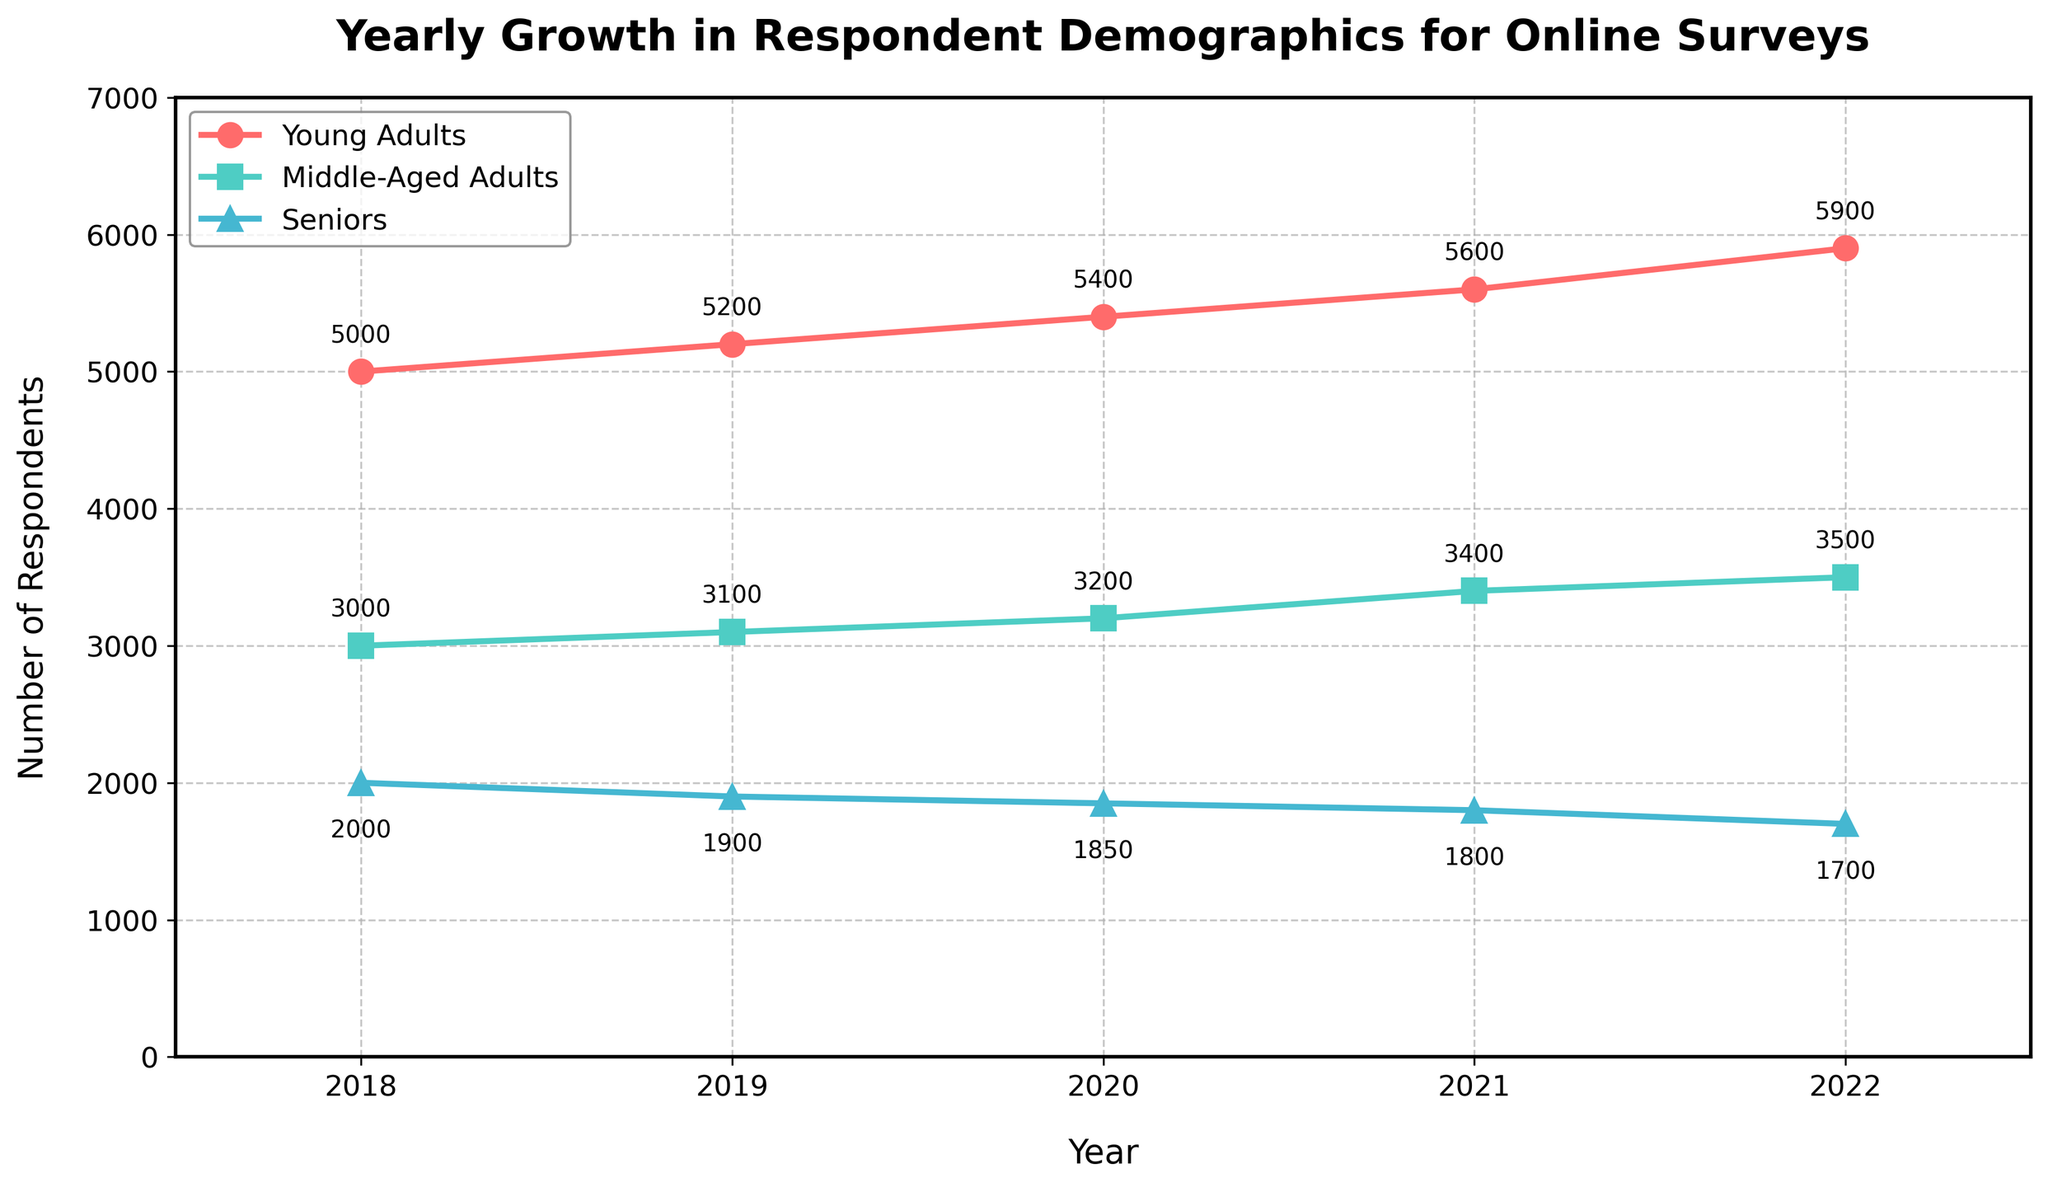What is the title of the plot? The title of the plot can be found at the top of the figure, stating the main subject being visualized. The title reads 'Yearly Growth in Respondent Demographics for Online Surveys'.
Answer: Yearly Growth in Respondent Demographics for Online Surveys What is the number of respondents in the Young Adults group in 2022? Locate the point for the year 2022 on the x-axis and then find the corresponding value on the y-axis for the Young Adults group, which is marked with red circles. The number next to the point indicates the value.
Answer: 5900 Which year had the highest number of Middle-Aged Adult respondents? Compare the values for Middle-Aged Adults, marked with green squares, across all years. The highest value is found in 2022.
Answer: 2022 What was the trend for the Seniors group from 2018 to 2022? Follow the points for the Seniors group, marked with blue triangles, from 2018 to 2022. The plot shows a decline over these years.
Answer: Declining How many more Young Adults were there than Seniors in 2021? Find the number of respondents for Young Adults and Seniors in 2021. Young Adults had 5600 respondents and Seniors had 1800. The difference is 5600 - 1800.
Answer: 3800 Which demographic group decreased over the years? Observe the overall trend lines for the three groups. The blue triangles representing Seniors show a decreasing trend.
Answer: Seniors What is the difference in the number of Middle-Aged Adults between 2018 and 2022? Find the number of Middle-Aged Adults in 2018 (3000) and in 2022 (3500). The difference is 3500 - 3000.
Answer: 500 How did the number of respondents for Young Adults change from 2019 to 2020? Locate the points for the years 2019 and 2020 for the Young Adults group, showing 5200 in 2019 and 5400 in 2020. The change is 5400 - 5200.
Answer: Increased by 200 What was the combined number of respondents for Middle-Aged Adults and Seniors in 2020? Sum the values for Middle-Aged Adults (3200) and Seniors (1850) in 2020. The combined number is 3200 + 1850.
Answer: 5050 